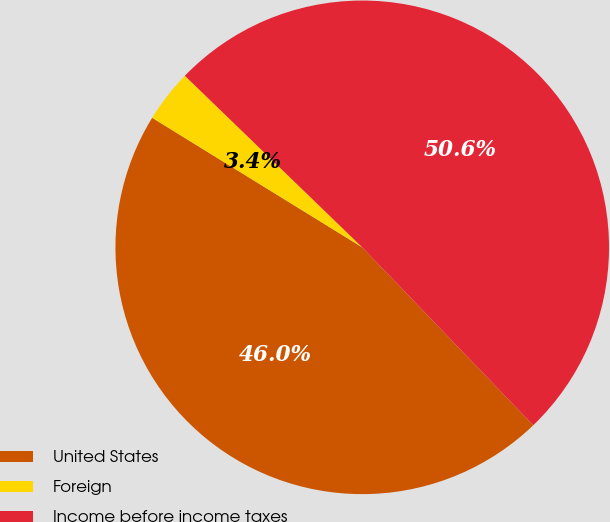Convert chart. <chart><loc_0><loc_0><loc_500><loc_500><pie_chart><fcel>United States<fcel>Foreign<fcel>Income before income taxes<nl><fcel>45.98%<fcel>3.44%<fcel>50.58%<nl></chart> 